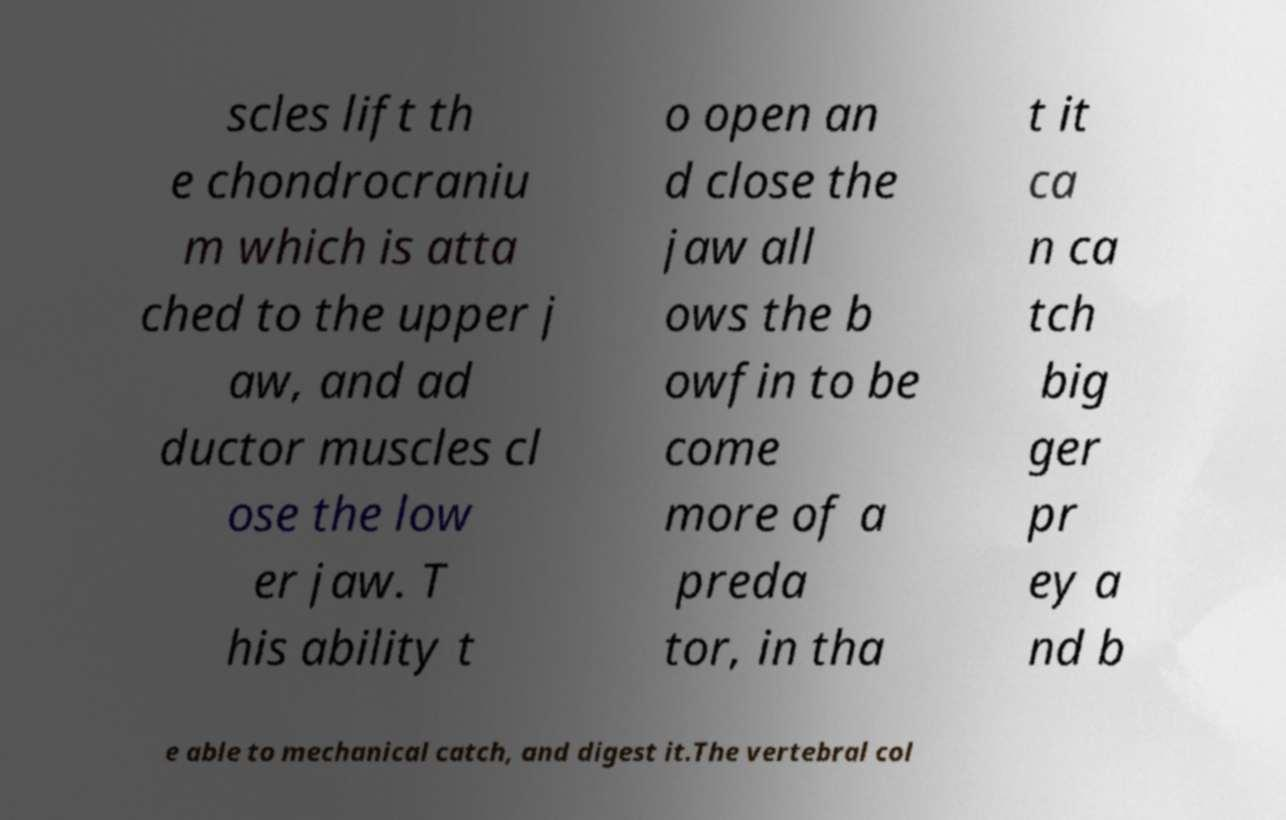Can you accurately transcribe the text from the provided image for me? scles lift th e chondrocraniu m which is atta ched to the upper j aw, and ad ductor muscles cl ose the low er jaw. T his ability t o open an d close the jaw all ows the b owfin to be come more of a preda tor, in tha t it ca n ca tch big ger pr ey a nd b e able to mechanical catch, and digest it.The vertebral col 